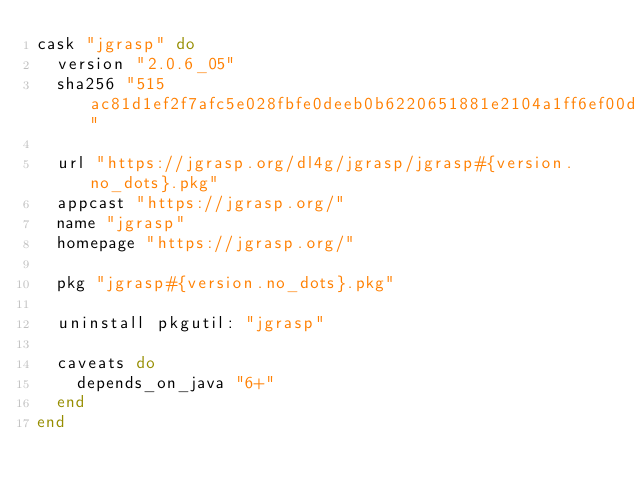Convert code to text. <code><loc_0><loc_0><loc_500><loc_500><_Ruby_>cask "jgrasp" do
  version "2.0.6_05"
  sha256 "515ac81d1ef2f7afc5e028fbfe0deeb0b6220651881e2104a1ff6ef00df49c70"

  url "https://jgrasp.org/dl4g/jgrasp/jgrasp#{version.no_dots}.pkg"
  appcast "https://jgrasp.org/"
  name "jgrasp"
  homepage "https://jgrasp.org/"

  pkg "jgrasp#{version.no_dots}.pkg"

  uninstall pkgutil: "jgrasp"

  caveats do
    depends_on_java "6+"
  end
end
</code> 